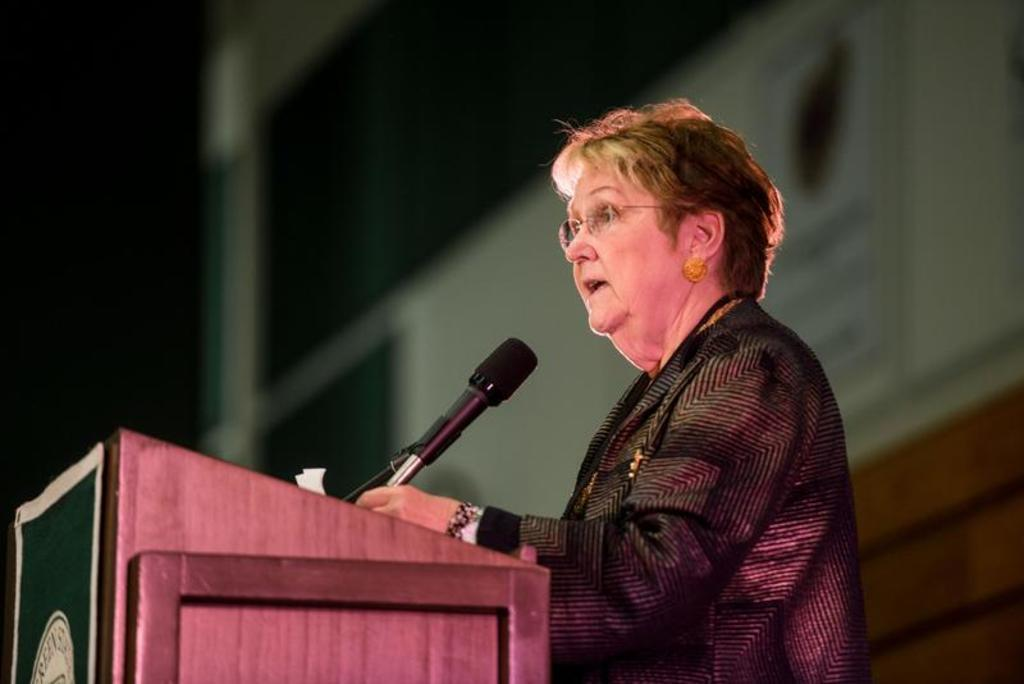Who is the main subject in the image? There is a woman in the image. What is the woman doing in the image? The woman is standing near a desk and talking into a microphone. Where is the microphone located in the image? The microphone is on the desk. What can be seen in the background of the image? There is a wall in the background of the image, and there is a screen on the wall. What type of attention is the woman receiving at the airport in the image? There is no airport present in the image, and the woman is not receiving any attention. 